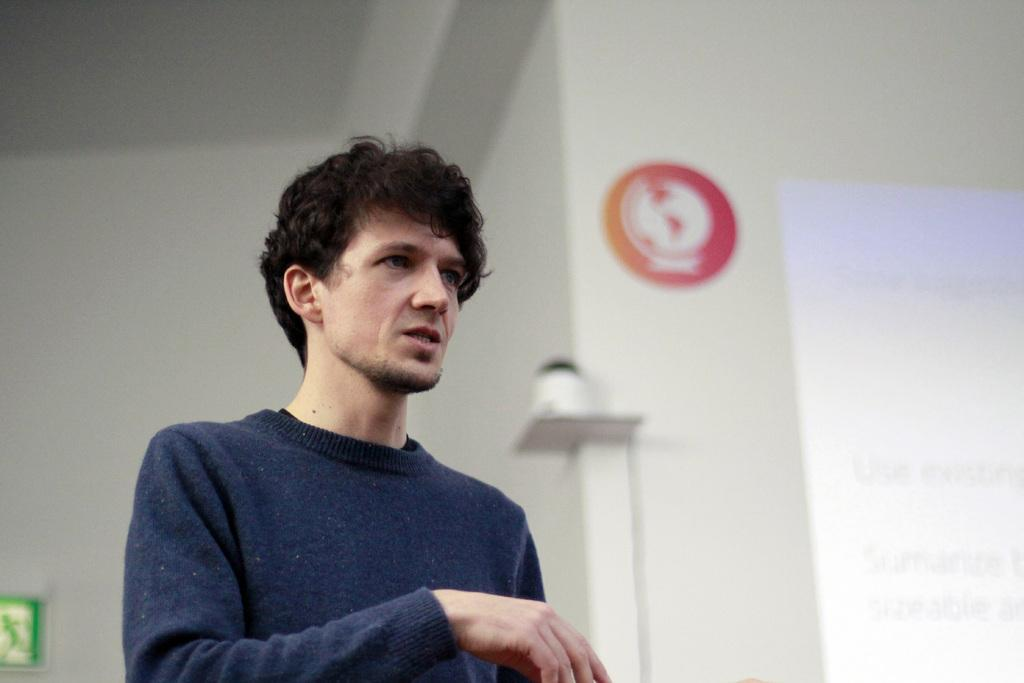What is the main subject of the image? There is a man standing in the image. What can be seen in the background of the image? There are walls and a display screen in the background of the image. What type of yarn is the man using to spy on the display screen in the image? There is no yarn or spying activity present in the image. The man is simply standing, and there is a display screen in the background. 